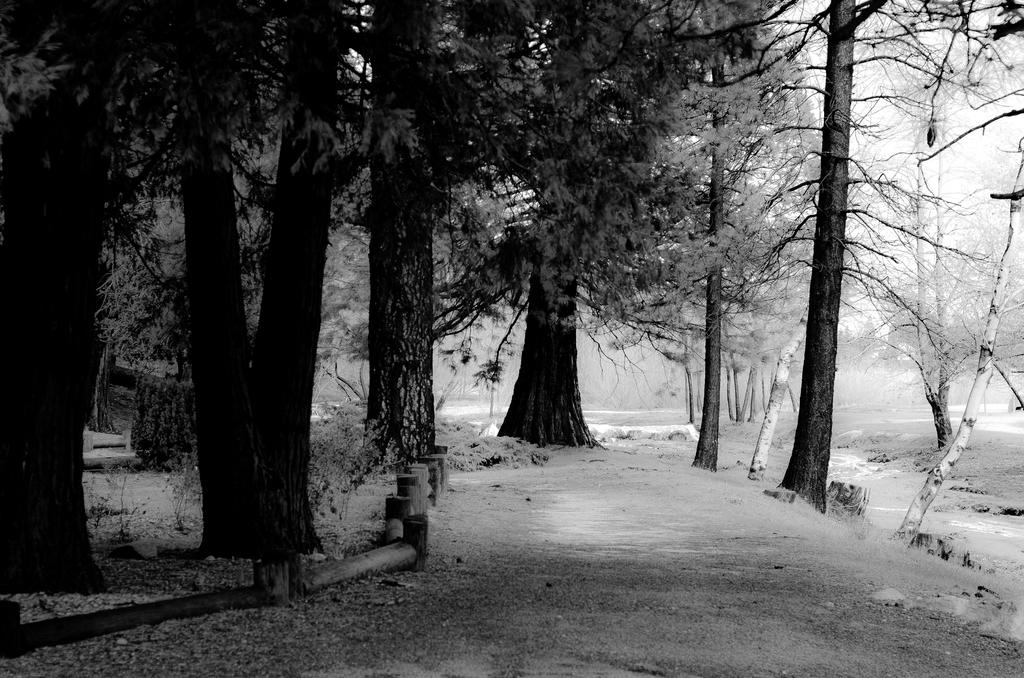What type of vegetation can be seen in the image? There are trees and plants in the image. What is the weather like in the image? There is snow in the image, indicating a cold or wintery environment. What can be seen in the background of the image? The sky is visible in the background of the image. How many fish are swimming in the snow in the image? There are no fish present in the image, as it features snow and vegetation. 